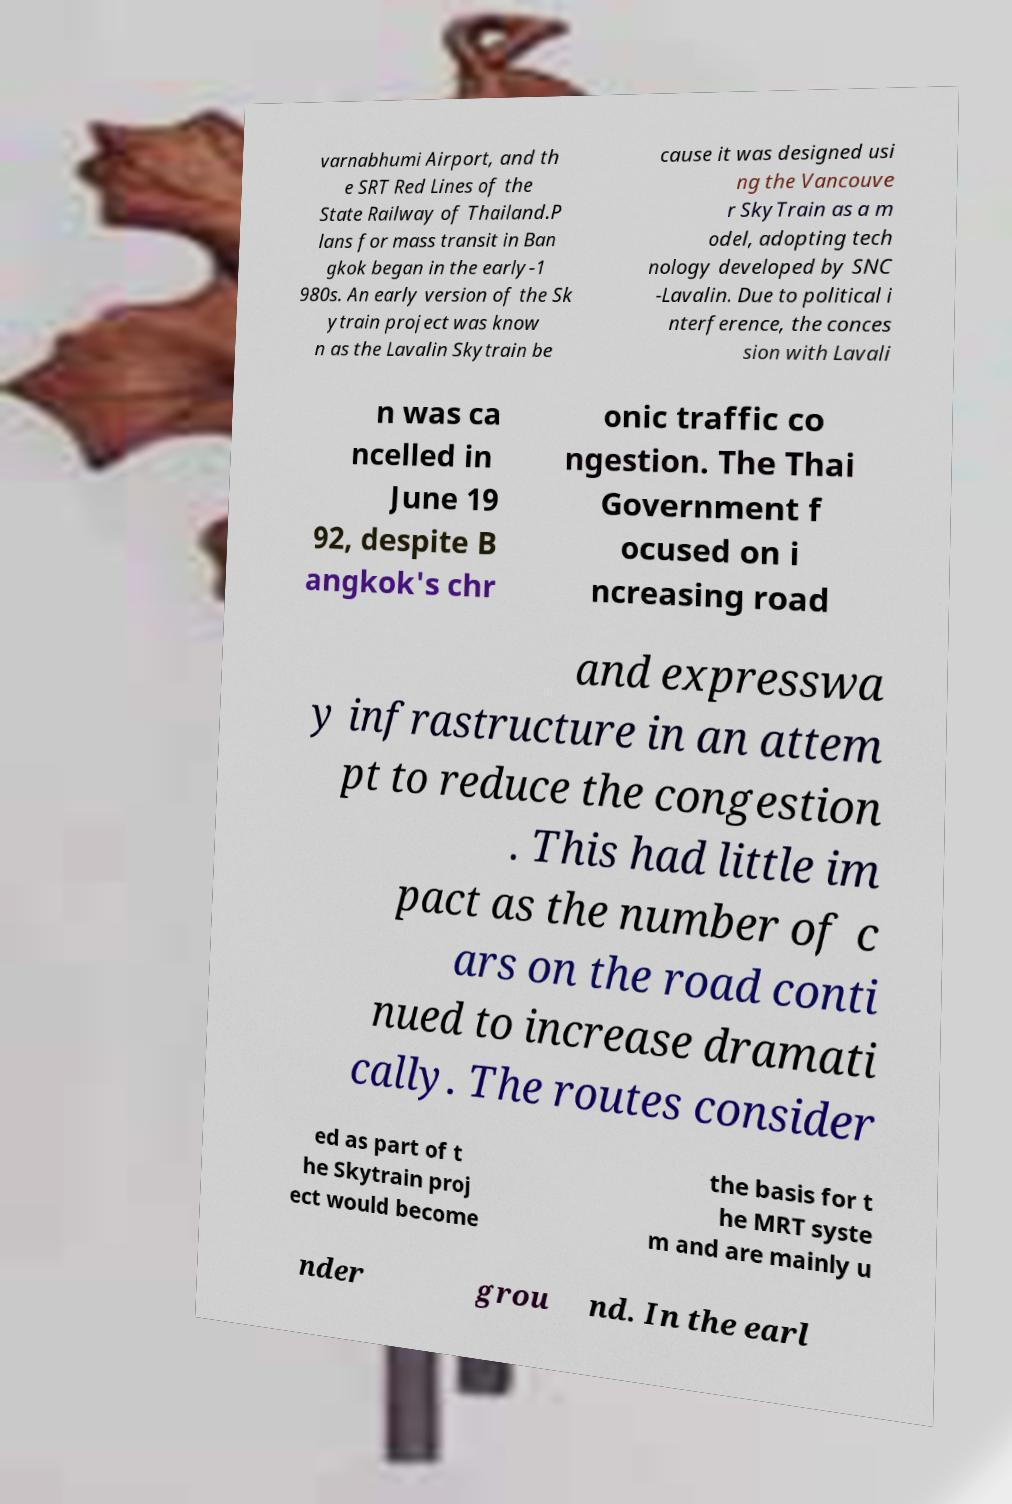Please identify and transcribe the text found in this image. varnabhumi Airport, and th e SRT Red Lines of the State Railway of Thailand.P lans for mass transit in Ban gkok began in the early-1 980s. An early version of the Sk ytrain project was know n as the Lavalin Skytrain be cause it was designed usi ng the Vancouve r SkyTrain as a m odel, adopting tech nology developed by SNC -Lavalin. Due to political i nterference, the conces sion with Lavali n was ca ncelled in June 19 92, despite B angkok's chr onic traffic co ngestion. The Thai Government f ocused on i ncreasing road and expresswa y infrastructure in an attem pt to reduce the congestion . This had little im pact as the number of c ars on the road conti nued to increase dramati cally. The routes consider ed as part of t he Skytrain proj ect would become the basis for t he MRT syste m and are mainly u nder grou nd. In the earl 